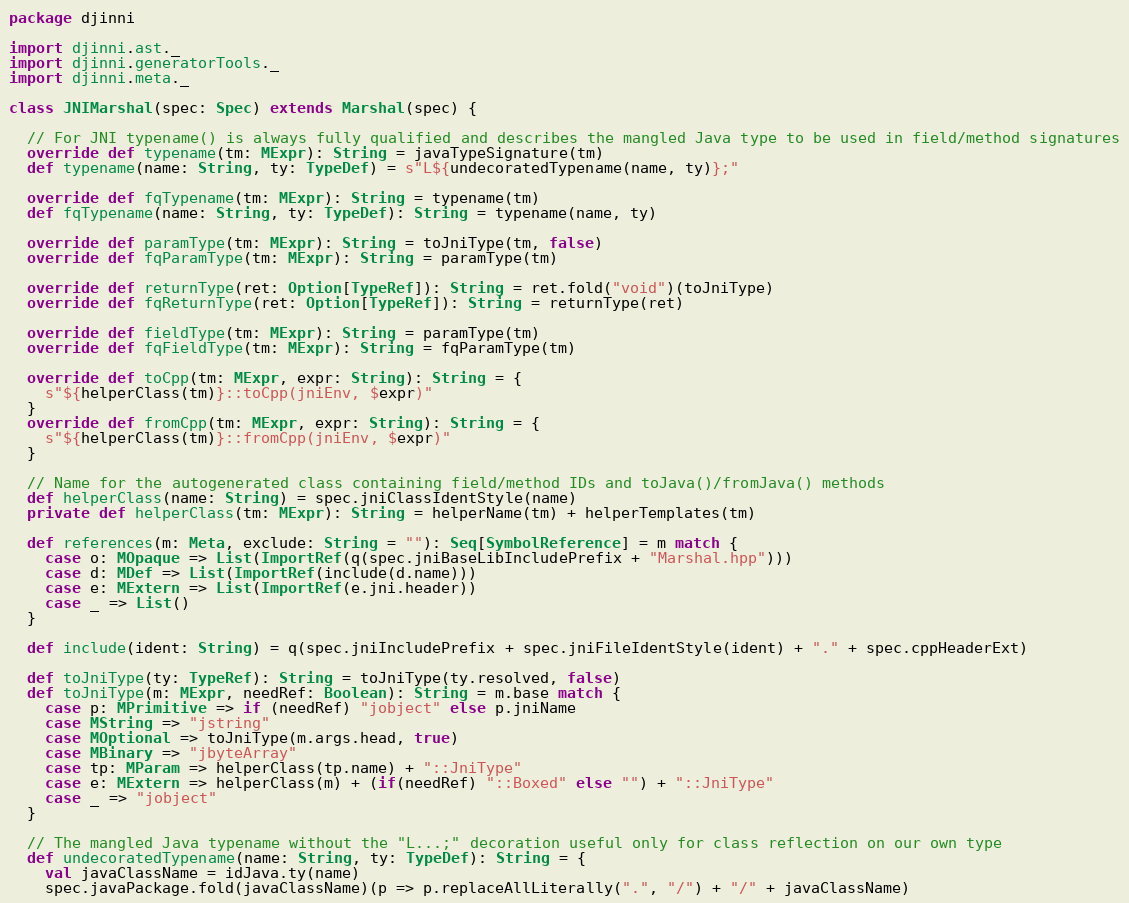Convert code to text. <code><loc_0><loc_0><loc_500><loc_500><_Scala_>package djinni

import djinni.ast._
import djinni.generatorTools._
import djinni.meta._

class JNIMarshal(spec: Spec) extends Marshal(spec) {

  // For JNI typename() is always fully qualified and describes the mangled Java type to be used in field/method signatures
  override def typename(tm: MExpr): String = javaTypeSignature(tm)
  def typename(name: String, ty: TypeDef) = s"L${undecoratedTypename(name, ty)};"

  override def fqTypename(tm: MExpr): String = typename(tm)
  def fqTypename(name: String, ty: TypeDef): String = typename(name, ty)

  override def paramType(tm: MExpr): String = toJniType(tm, false)
  override def fqParamType(tm: MExpr): String = paramType(tm)

  override def returnType(ret: Option[TypeRef]): String = ret.fold("void")(toJniType)
  override def fqReturnType(ret: Option[TypeRef]): String = returnType(ret)

  override def fieldType(tm: MExpr): String = paramType(tm)
  override def fqFieldType(tm: MExpr): String = fqParamType(tm)

  override def toCpp(tm: MExpr, expr: String): String = {
    s"${helperClass(tm)}::toCpp(jniEnv, $expr)"
  }
  override def fromCpp(tm: MExpr, expr: String): String = {
    s"${helperClass(tm)}::fromCpp(jniEnv, $expr)"
  }

  // Name for the autogenerated class containing field/method IDs and toJava()/fromJava() methods
  def helperClass(name: String) = spec.jniClassIdentStyle(name)
  private def helperClass(tm: MExpr): String = helperName(tm) + helperTemplates(tm)

  def references(m: Meta, exclude: String = ""): Seq[SymbolReference] = m match {
    case o: MOpaque => List(ImportRef(q(spec.jniBaseLibIncludePrefix + "Marshal.hpp")))
    case d: MDef => List(ImportRef(include(d.name)))
    case e: MExtern => List(ImportRef(e.jni.header))
    case _ => List()
  }

  def include(ident: String) = q(spec.jniIncludePrefix + spec.jniFileIdentStyle(ident) + "." + spec.cppHeaderExt)

  def toJniType(ty: TypeRef): String = toJniType(ty.resolved, false)
  def toJniType(m: MExpr, needRef: Boolean): String = m.base match {
    case p: MPrimitive => if (needRef) "jobject" else p.jniName
    case MString => "jstring"
    case MOptional => toJniType(m.args.head, true)
    case MBinary => "jbyteArray"
    case tp: MParam => helperClass(tp.name) + "::JniType"
    case e: MExtern => helperClass(m) + (if(needRef) "::Boxed" else "") + "::JniType"
    case _ => "jobject"
  }

  // The mangled Java typename without the "L...;" decoration useful only for class reflection on our own type
  def undecoratedTypename(name: String, ty: TypeDef): String = {
    val javaClassName = idJava.ty(name)
    spec.javaPackage.fold(javaClassName)(p => p.replaceAllLiterally(".", "/") + "/" + javaClassName)</code> 